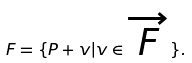Convert formula to latex. <formula><loc_0><loc_0><loc_500><loc_500>F = \{ P + v | v \in { \overrightarrow { F } } \} .</formula> 